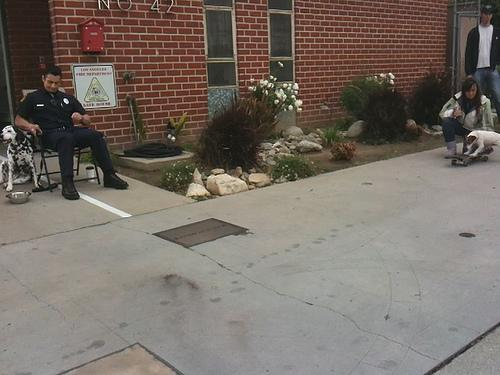Who is the man sitting by the building entrance?

Choices:
A) security guard
B) driver
C) receptionist
D) greeter security guard 